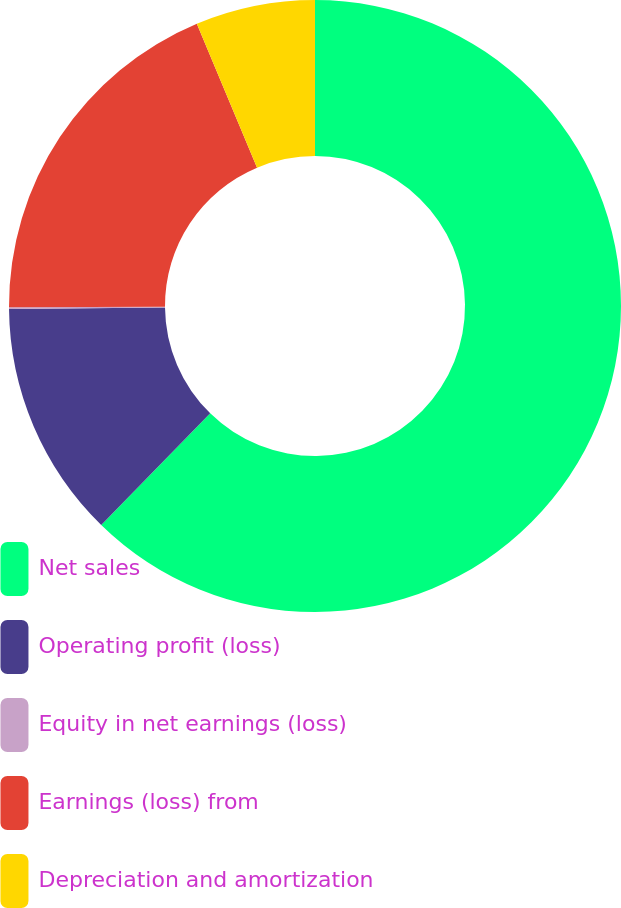Convert chart to OTSL. <chart><loc_0><loc_0><loc_500><loc_500><pie_chart><fcel>Net sales<fcel>Operating profit (loss)<fcel>Equity in net earnings (loss)<fcel>Earnings (loss) from<fcel>Depreciation and amortization<nl><fcel>62.31%<fcel>12.53%<fcel>0.09%<fcel>18.76%<fcel>6.31%<nl></chart> 